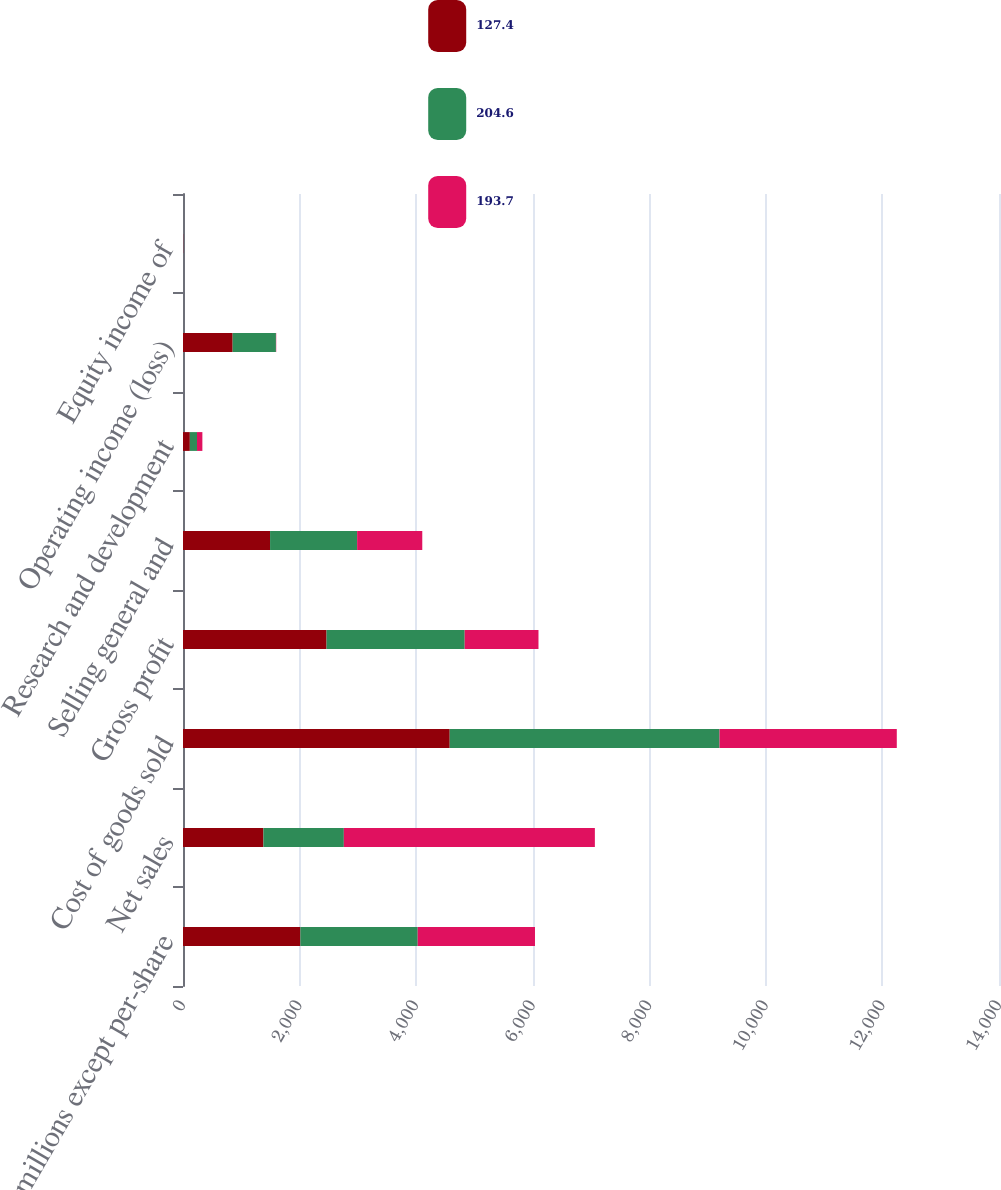Convert chart. <chart><loc_0><loc_0><loc_500><loc_500><stacked_bar_chart><ecel><fcel>In millions except per-share<fcel>Net sales<fcel>Cost of goods sold<fcel>Gross profit<fcel>Selling general and<fcel>Research and development<fcel>Operating income (loss)<fcel>Equity income of<nl><fcel>127.4<fcel>2014<fcel>1379.8<fcel>4576<fcel>2463<fcel>1493.8<fcel>117.3<fcel>851.9<fcel>1.2<nl><fcel>204.6<fcel>2013<fcel>1379.8<fcel>4629.6<fcel>2370.1<fcel>1493.7<fcel>122.8<fcel>742.6<fcel>2<nl><fcel>193.7<fcel>2012<fcel>4306.8<fcel>3040.9<fcel>1265.9<fcel>1117.7<fcel>92.3<fcel>4.8<fcel>2.3<nl></chart> 